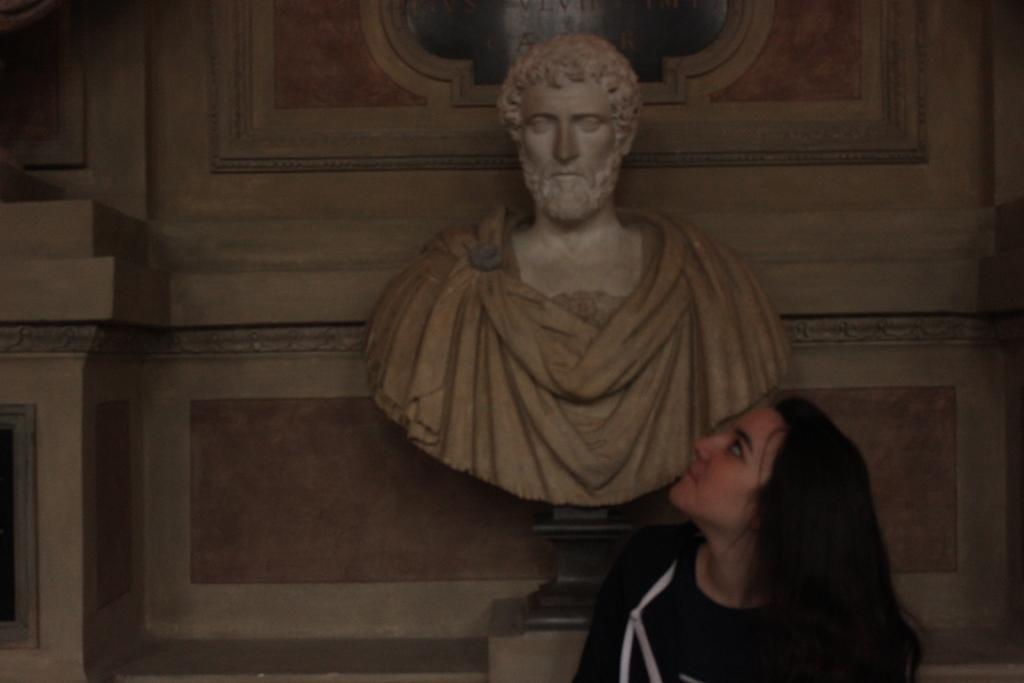In one or two sentences, can you explain what this image depicts? In the picture we can see a woman standing near the wall and looking upwards and she is with black T-shirt and behind her we can see a sculpture of a man with a stand and behind it we can see a wall with designs to it. 